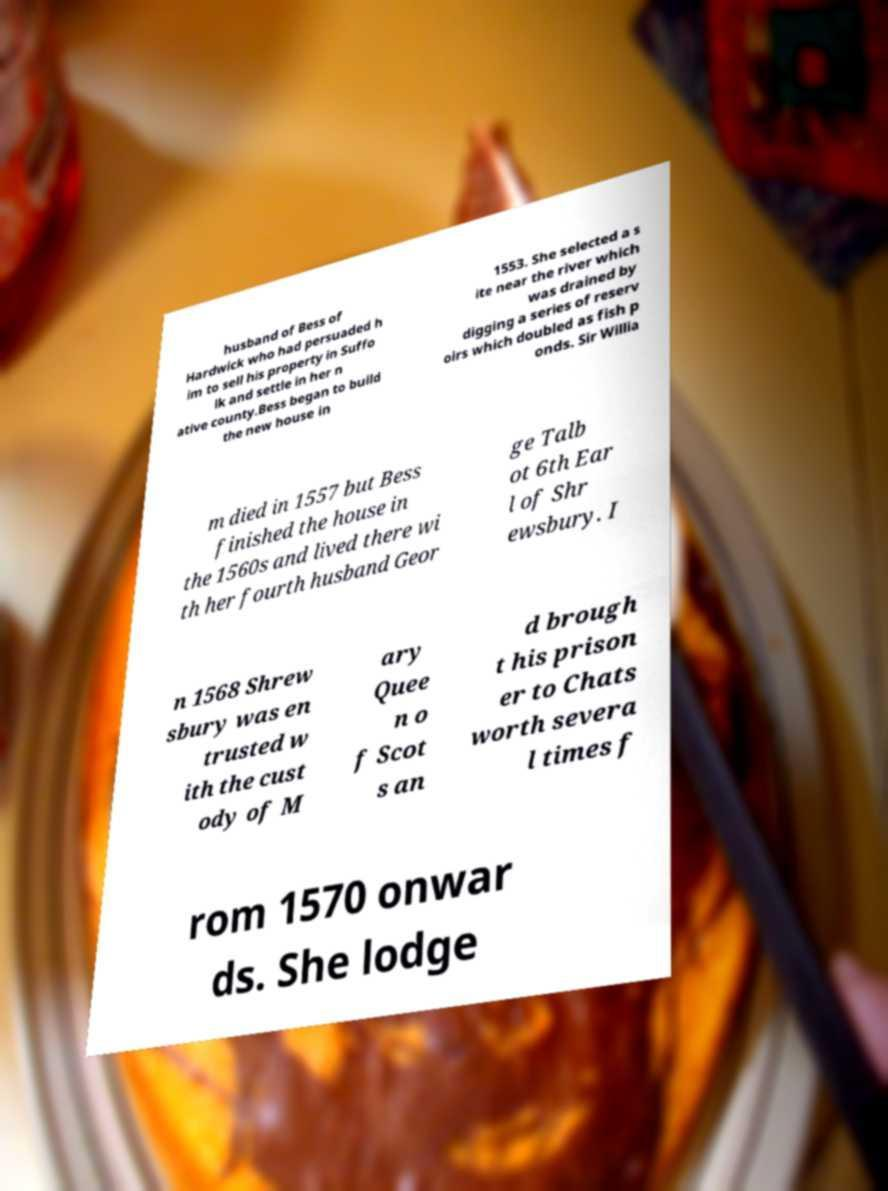Please read and relay the text visible in this image. What does it say? husband of Bess of Hardwick who had persuaded h im to sell his property in Suffo lk and settle in her n ative county.Bess began to build the new house in 1553. She selected a s ite near the river which was drained by digging a series of reserv oirs which doubled as fish p onds. Sir Willia m died in 1557 but Bess finished the house in the 1560s and lived there wi th her fourth husband Geor ge Talb ot 6th Ear l of Shr ewsbury. I n 1568 Shrew sbury was en trusted w ith the cust ody of M ary Quee n o f Scot s an d brough t his prison er to Chats worth severa l times f rom 1570 onwar ds. She lodge 